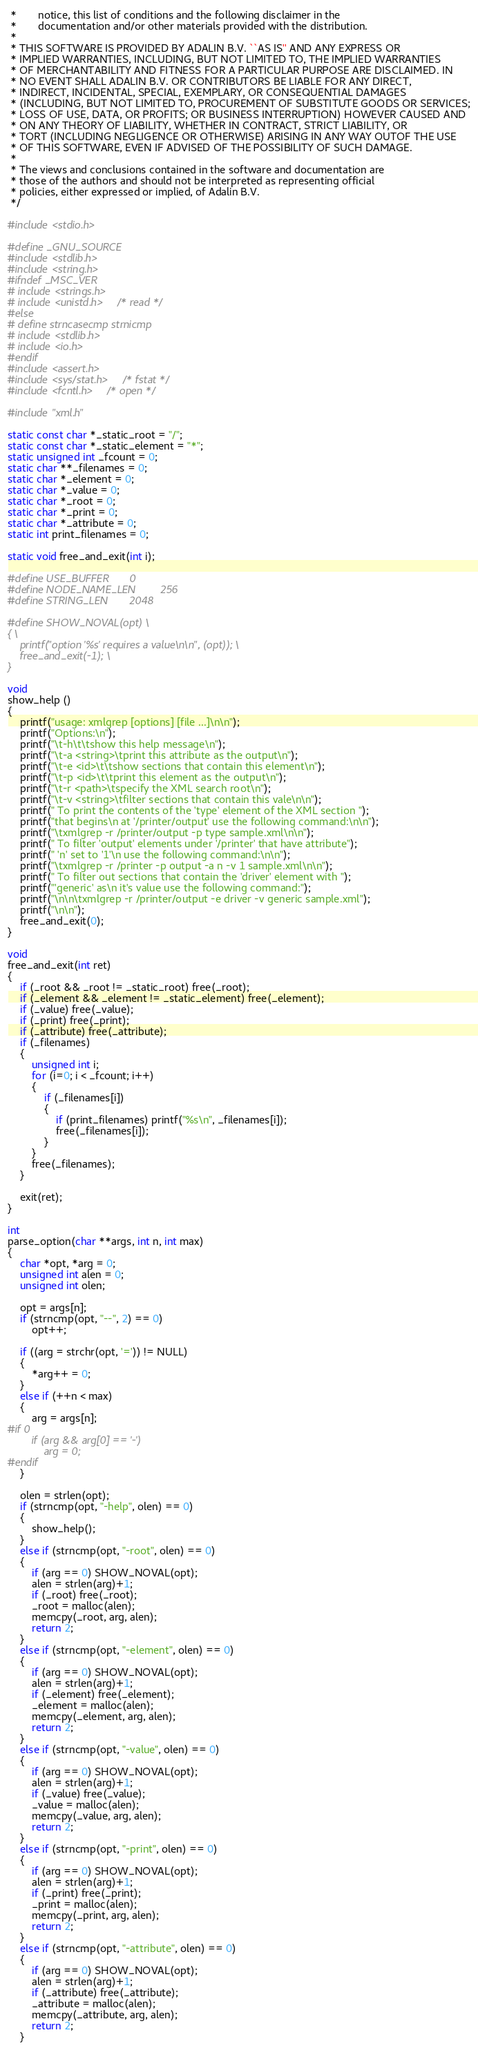<code> <loc_0><loc_0><loc_500><loc_500><_C_> *       notice, this list of conditions and the following disclaimer in the
 *       documentation and/or other materials provided with the distribution.
 * 
 * THIS SOFTWARE IS PROVIDED BY ADALIN B.V. ``AS IS'' AND ANY EXPRESS OR
 * IMPLIED WARRANTIES, INCLUDING, BUT NOT LIMITED TO, THE IMPLIED WARRANTIES
 * OF MERCHANTABILITY AND FITNESS FOR A PARTICULAR PURPOSE ARE DISCLAIMED. IN
 * NO EVENT SHALL ADALIN B.V. OR CONTRIBUTORS BE LIABLE FOR ANY DIRECT,
 * INDIRECT, INCIDENTAL, SPECIAL, EXEMPLARY, OR CONSEQUENTIAL DAMAGES 
 * (INCLUDING, BUT NOT LIMITED TO, PROCUREMENT OF SUBSTITUTE GOODS OR SERVICES;
 * LOSS OF USE, DATA, OR PROFITS; OR BUSINESS INTERRUPTION) HOWEVER CAUSED AND
 * ON ANY THEORY OF LIABILITY, WHETHER IN CONTRACT, STRICT LIABILITY, OR 
 * TORT (INCLUDING NEGLIGENCE OR OTHERWISE) ARISING IN ANY WAY OUTOF THE USE 
 * OF THIS SOFTWARE, EVEN IF ADVISED OF THE POSSIBILITY OF SUCH DAMAGE.
 *
 * The views and conclusions contained in the software and documentation are
 * those of the authors and should not be interpreted as representing official
 * policies, either expressed or implied, of Adalin B.V.
 */

#include <stdio.h>

#define _GNU_SOURCE
#include <stdlib.h>
#include <string.h>
#ifndef _MSC_VER
# include <strings.h>
# include <unistd.h>	/* read */
#else
# define strncasecmp strnicmp
# include <stdlib.h>
# include <io.h>
#endif
#include <assert.h>
#include <sys/stat.h>	/* fstat */
#include <fcntl.h>	/* open */

#include "xml.h"

static const char *_static_root = "/";
static const char *_static_element = "*";
static unsigned int _fcount = 0;
static char **_filenames = 0;
static char *_element = 0;
static char *_value = 0;
static char *_root = 0;
static char *_print = 0;
static char *_attribute = 0;
static int print_filenames = 0;

static void free_and_exit(int i);

#define USE_BUFFER		0
#define NODE_NAME_LEN		256
#define STRING_LEN		2048

#define SHOW_NOVAL(opt) \
{ \
    printf("option '%s' requires a value\n\n", (opt)); \
    free_and_exit(-1); \
}

void
show_help ()
{
    printf("usage: xmlgrep [options] [file ...]\n\n");
    printf("Options:\n");
    printf("\t-h\t\tshow this help message\n");
    printf("\t-a <string>\tprint this attribute as the output\n");
    printf("\t-e <id>\t\tshow sections that contain this element\n");
    printf("\t-p <id>\t\tprint this element as the output\n");
    printf("\t-r <path>\tspecify the XML search root\n");
    printf("\t-v <string>\tfilter sections that contain this vale\n\n");
    printf(" To print the contents of the 'type' element of the XML section ");
    printf("that begins\n at '/printer/output' use the following command:\n\n");
    printf("\txmlgrep -r /printer/output -p type sample.xml\n\n");
    printf(" To filter 'output' elements under '/printer' that have attribute");
    printf(" 'n' set to '1'\n use the following command:\n\n");
    printf("\txmlgrep -r /printer -p output -a n -v 1 sample.xml\n\n");
    printf(" To filter out sections that contain the 'driver' element with ");
    printf("'generic' as\n it's value use the following command:");
    printf("\n\n\txmlgrep -r /printer/output -e driver -v generic sample.xml");
    printf("\n\n");
    free_and_exit(0);
}

void
free_and_exit(int ret)
{
    if (_root && _root != _static_root) free(_root);
    if (_element && _element != _static_element) free(_element);
    if (_value) free(_value);
    if (_print) free(_print);
    if (_attribute) free(_attribute);
    if (_filenames)
    {
        unsigned int i;
        for (i=0; i < _fcount; i++)
        {
            if (_filenames[i])
            {
                if (print_filenames) printf("%s\n", _filenames[i]);
                free(_filenames[i]);
            }
        }
        free(_filenames);
    }
 
    exit(ret);
}

int
parse_option(char **args, int n, int max)
{
    char *opt, *arg = 0;
    unsigned int alen = 0;
    unsigned int olen;

    opt = args[n];
    if (strncmp(opt, "--", 2) == 0)
        opt++;

    if ((arg = strchr(opt, '=')) != NULL)
    {
        *arg++ = 0;
    }
    else if (++n < max)
    {
        arg = args[n];
#if 0
        if (arg && arg[0] == '-')
            arg = 0;
#endif
    }

    olen = strlen(opt);
    if (strncmp(opt, "-help", olen) == 0)
    {
        show_help();
    }
    else if (strncmp(opt, "-root", olen) == 0)
    {
        if (arg == 0) SHOW_NOVAL(opt);
        alen = strlen(arg)+1;
        if (_root) free(_root);
        _root = malloc(alen);
        memcpy(_root, arg, alen);
        return 2;
    }
    else if (strncmp(opt, "-element", olen) == 0)
    {
        if (arg == 0) SHOW_NOVAL(opt);
        alen = strlen(arg)+1;
        if (_element) free(_element);
        _element = malloc(alen);
        memcpy(_element, arg, alen);
        return 2;
    }
    else if (strncmp(opt, "-value", olen) == 0)
    {
        if (arg == 0) SHOW_NOVAL(opt);
        alen = strlen(arg)+1;
        if (_value) free(_value);
        _value = malloc(alen);
        memcpy(_value, arg, alen);
        return 2;
    }
    else if (strncmp(opt, "-print", olen) == 0)
    {
        if (arg == 0) SHOW_NOVAL(opt);
        alen = strlen(arg)+1;
        if (_print) free(_print);
        _print = malloc(alen);
        memcpy(_print, arg, alen);
        return 2;
    }
    else if (strncmp(opt, "-attribute", olen) == 0)
    {
        if (arg == 0) SHOW_NOVAL(opt);
        alen = strlen(arg)+1;
        if (_attribute) free(_attribute);
        _attribute = malloc(alen);
        memcpy(_attribute, arg, alen);
        return 2;
    }</code> 